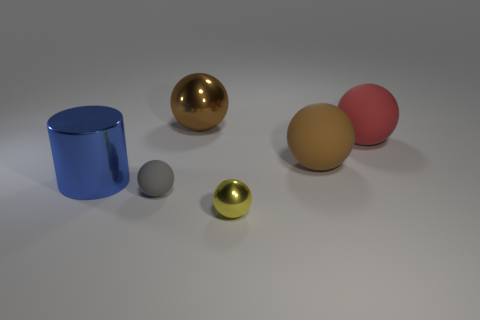Do the big metallic sphere and the matte ball that is in front of the big brown rubber object have the same color?
Provide a succinct answer. No. There is a big shiny thing behind the large blue cylinder; how many big shiny objects are in front of it?
Offer a terse response. 1. What is the size of the metal object that is on the right side of the big blue cylinder and behind the small gray object?
Provide a short and direct response. Large. Is there a rubber sphere of the same size as the brown rubber object?
Your answer should be very brief. Yes. Are there more blue shiny objects that are to the right of the shiny cylinder than gray rubber things on the left side of the gray matte thing?
Keep it short and to the point. No. Are the yellow thing and the large brown thing on the left side of the brown matte ball made of the same material?
Provide a short and direct response. Yes. How many big blue metallic things are left of the large brown ball that is on the left side of the small object that is to the right of the small rubber thing?
Keep it short and to the point. 1. Do the brown shiny object and the large matte object that is in front of the big red matte object have the same shape?
Give a very brief answer. Yes. What is the color of the large thing that is on the right side of the small yellow shiny object and behind the brown matte object?
Keep it short and to the point. Red. There is a big object to the right of the large brown thing to the right of the large brown ball behind the red thing; what is it made of?
Provide a succinct answer. Rubber. 